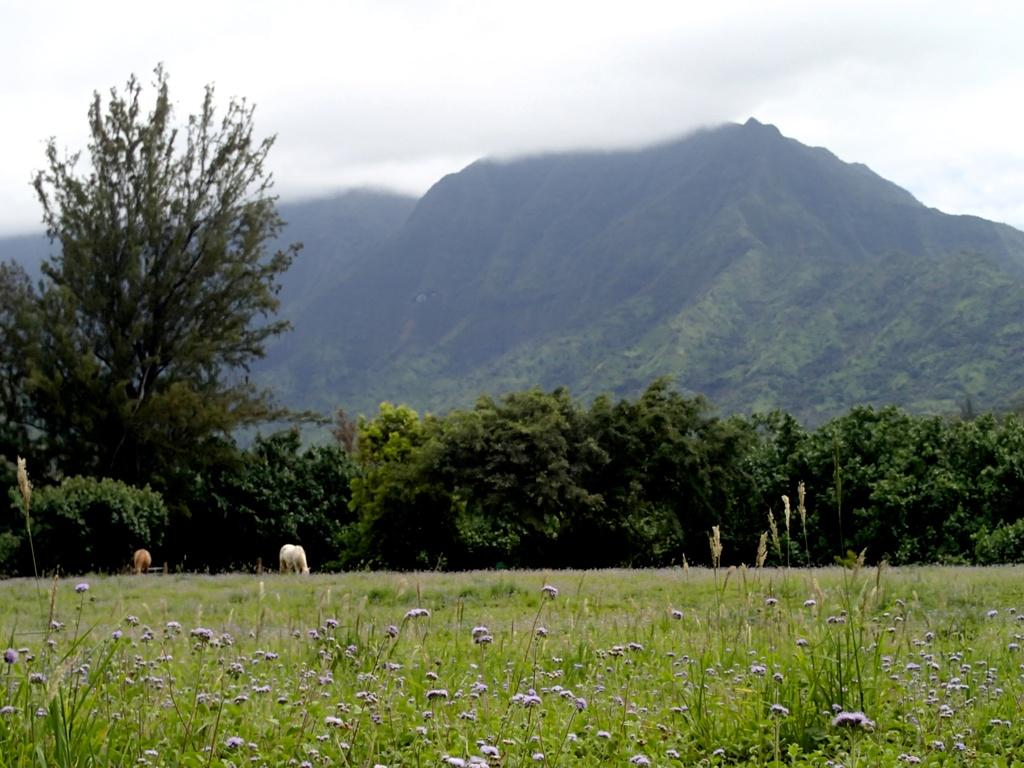What type of vegetation can be seen in the image? There is grass, plants, flowers, and trees in the image. Are there any living organisms visible in the image? Yes, there are animals in the image. What can be seen in the background of the image? There is a mountain and the sky visible in the background of the image. What type of quartz can be seen in the image? There is no quartz present in the image. Can you hear the animals in the image? The image is a visual representation, so it is not possible to hear the animals through the image. 